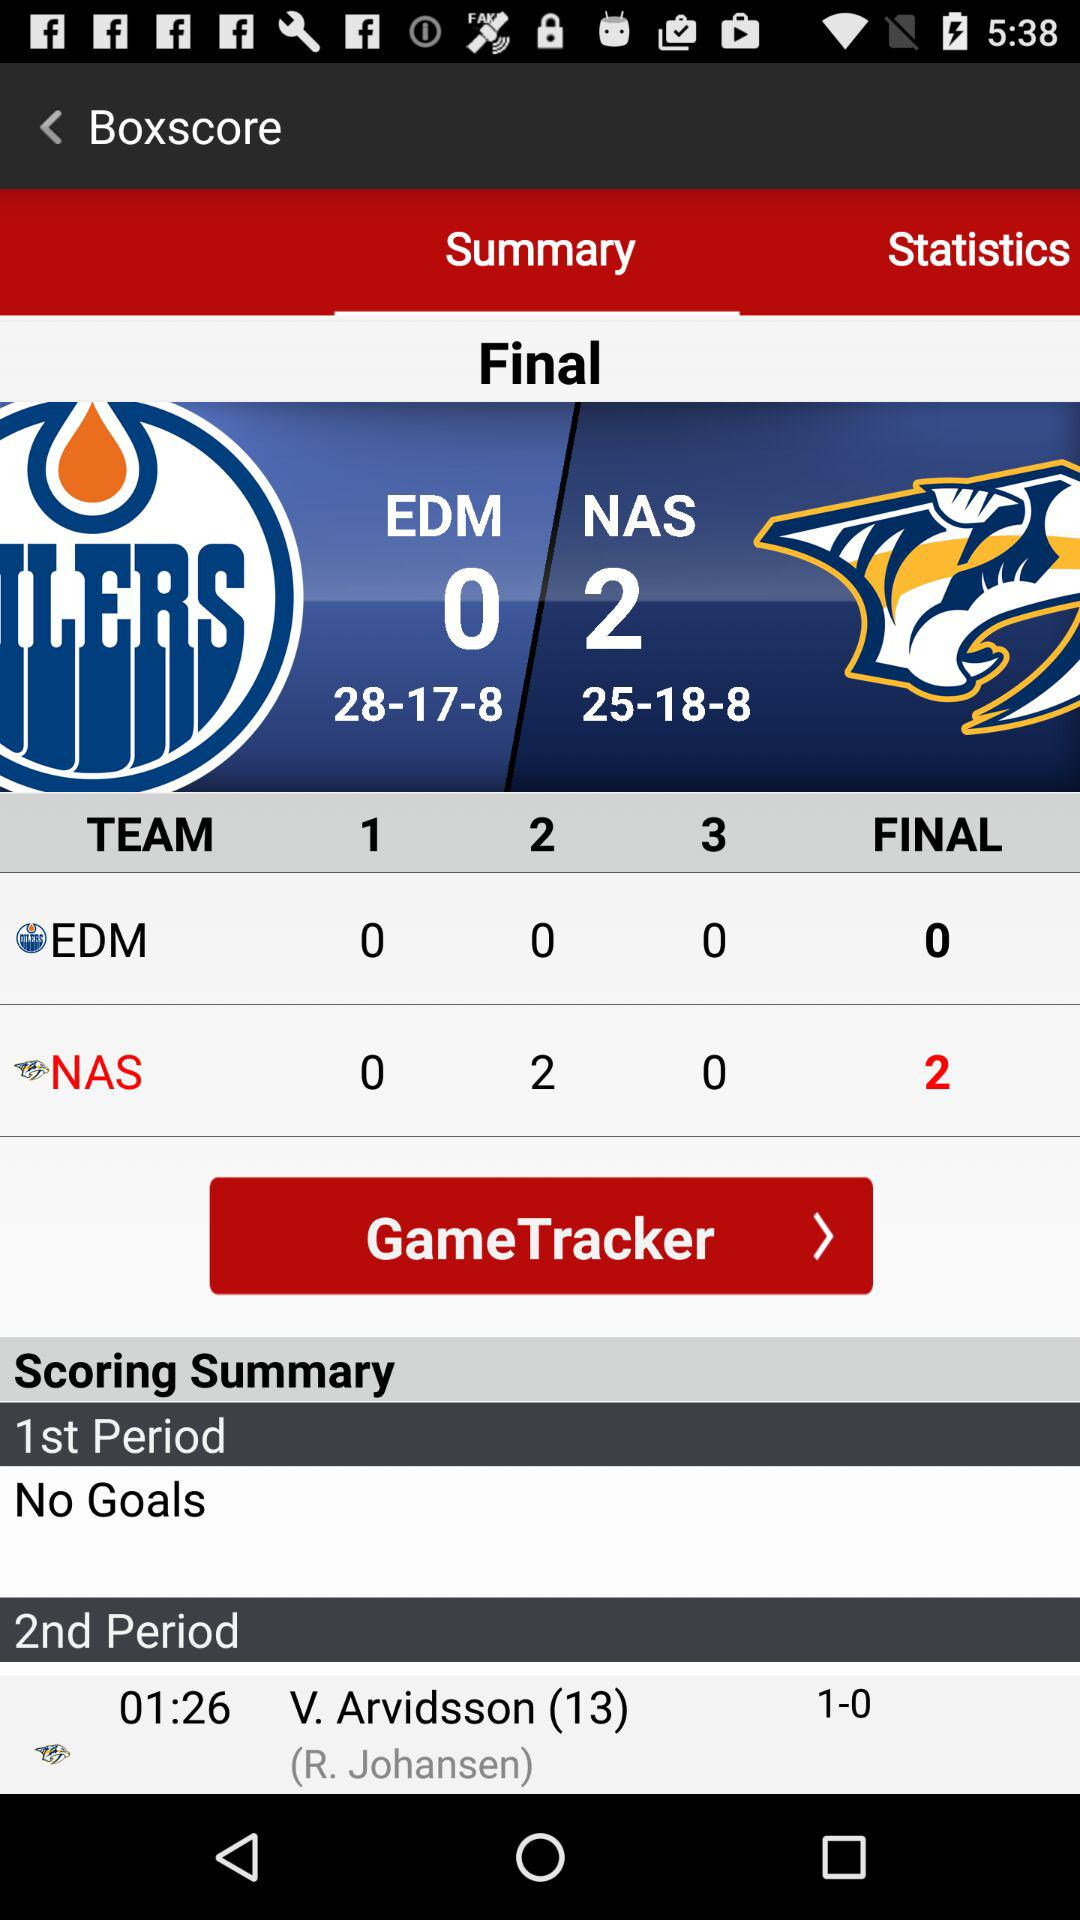What was the number of goals scored by the EDM team in the final? The number of goals scored by the EDM team in the final was 0. 